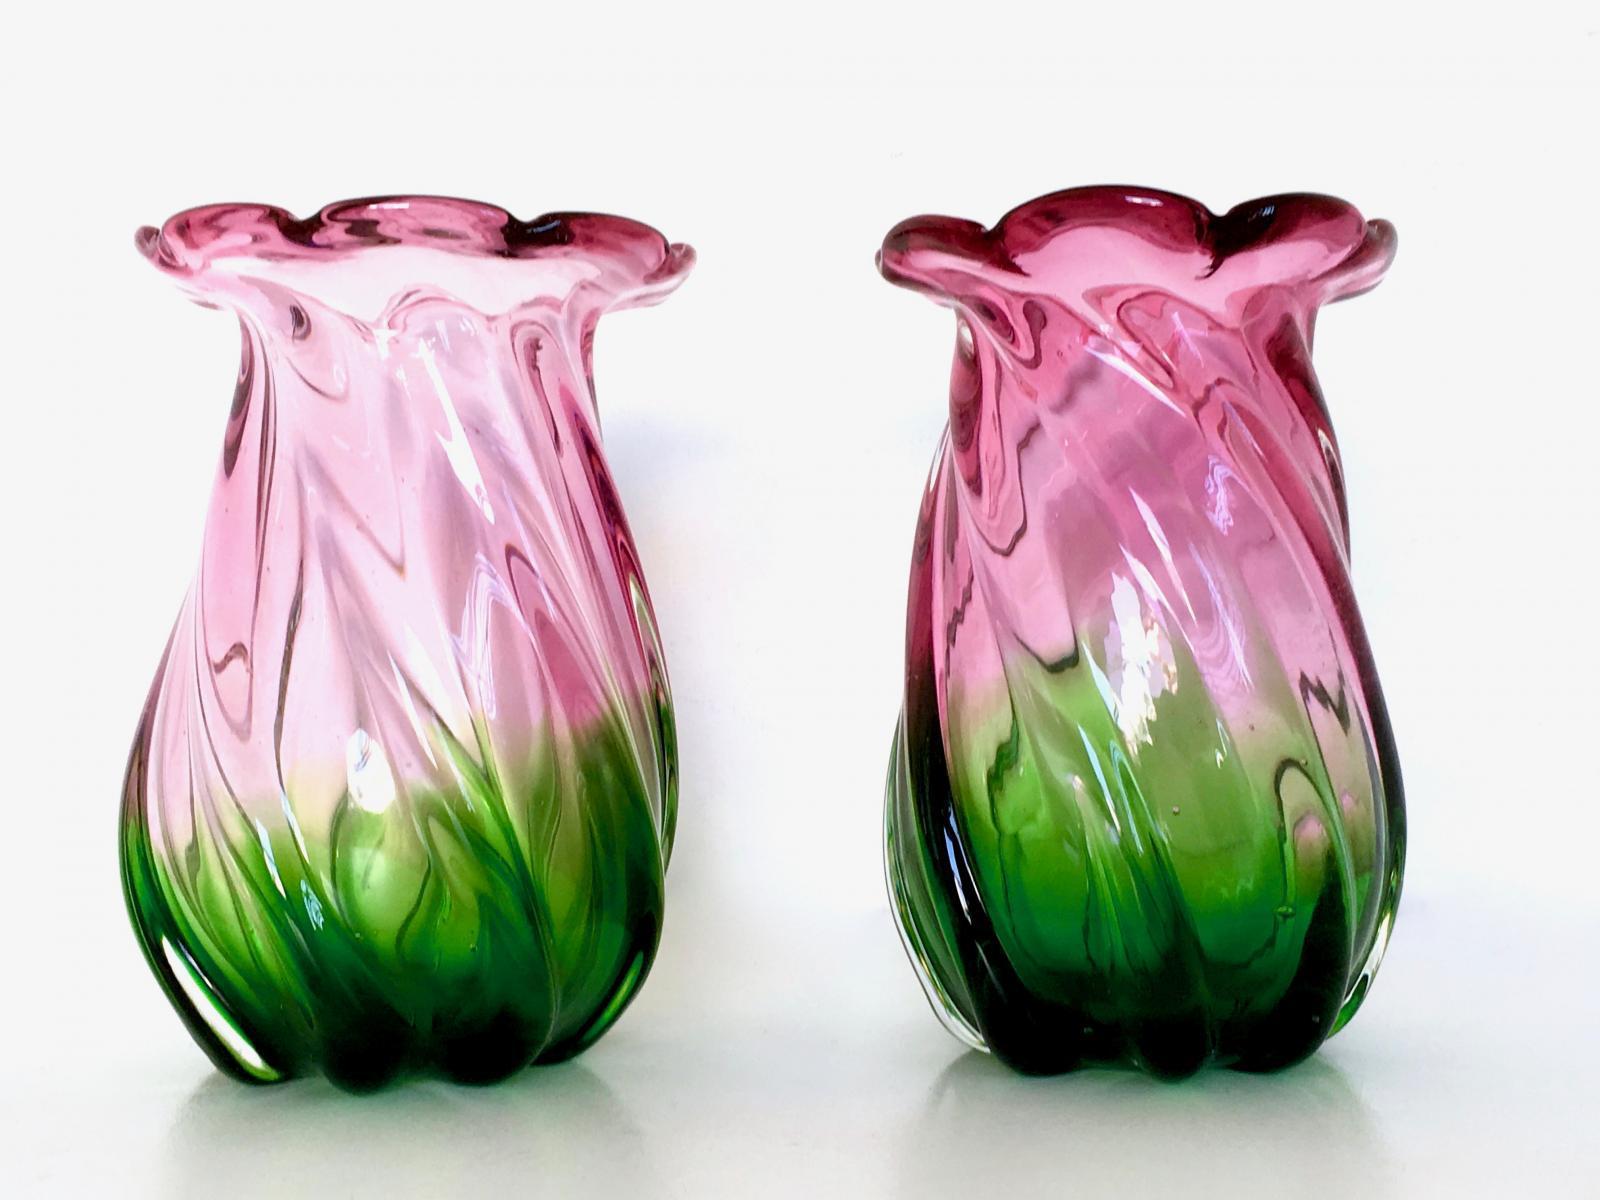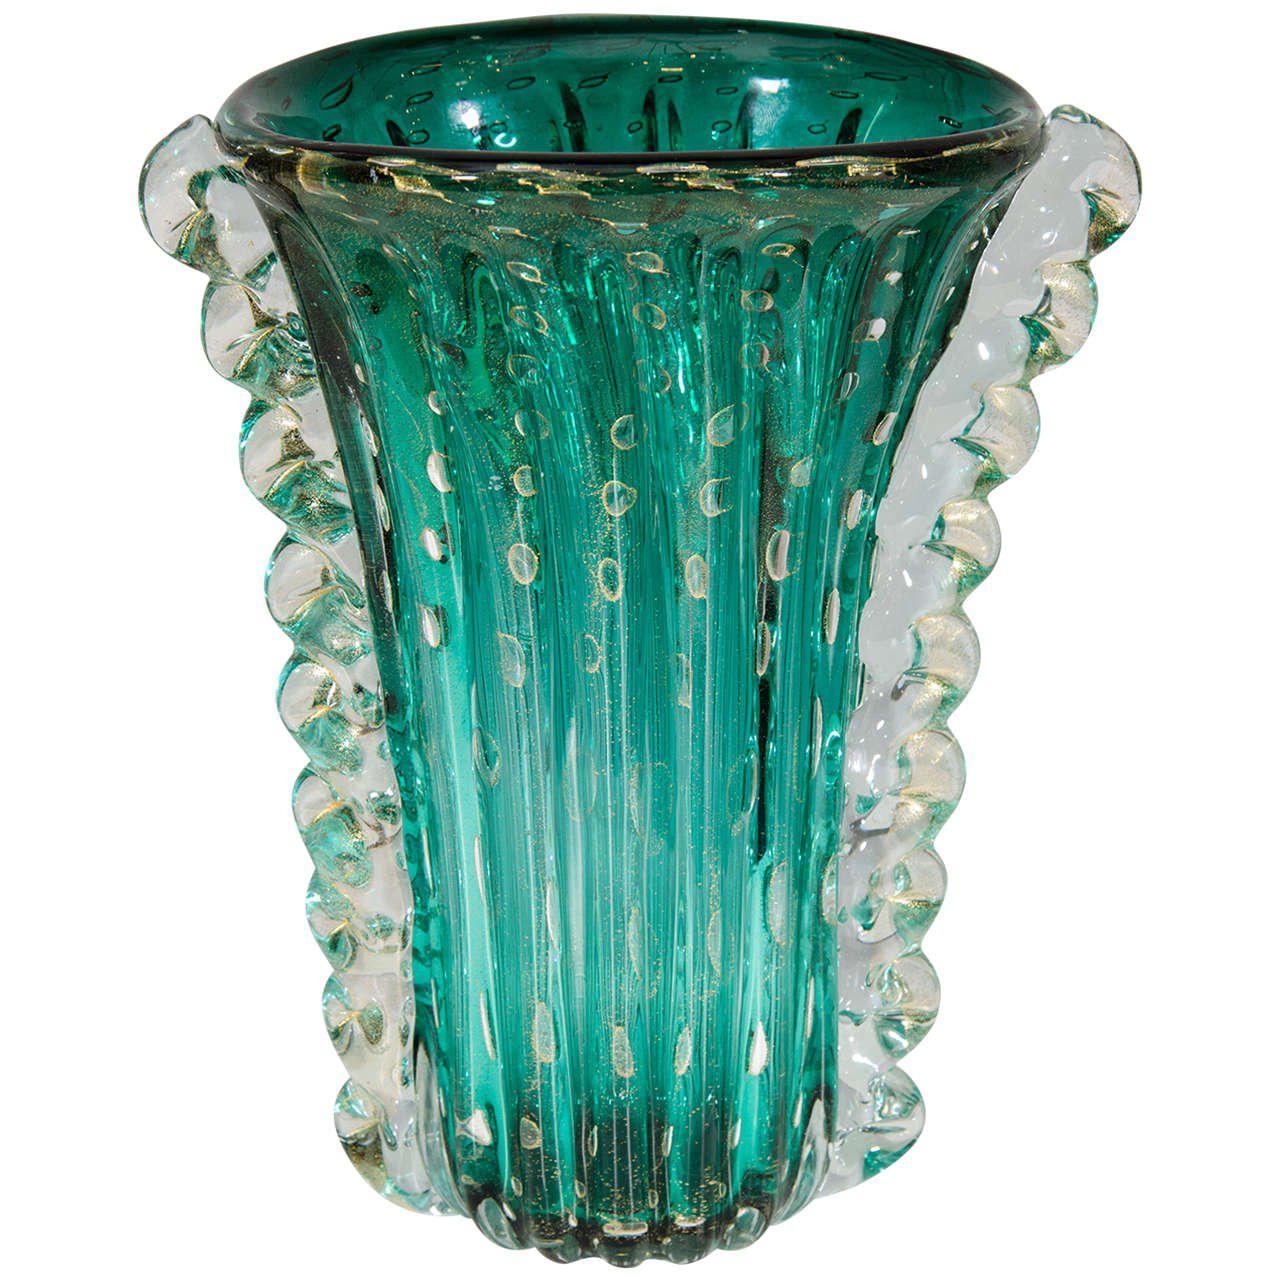The first image is the image on the left, the second image is the image on the right. Given the left and right images, does the statement "The vase in the right image is bluish-green, with no other bright colors on it." hold true? Answer yes or no. Yes. The first image is the image on the left, the second image is the image on the right. Considering the images on both sides, is "The vase on the right is a green color." valid? Answer yes or no. Yes. 